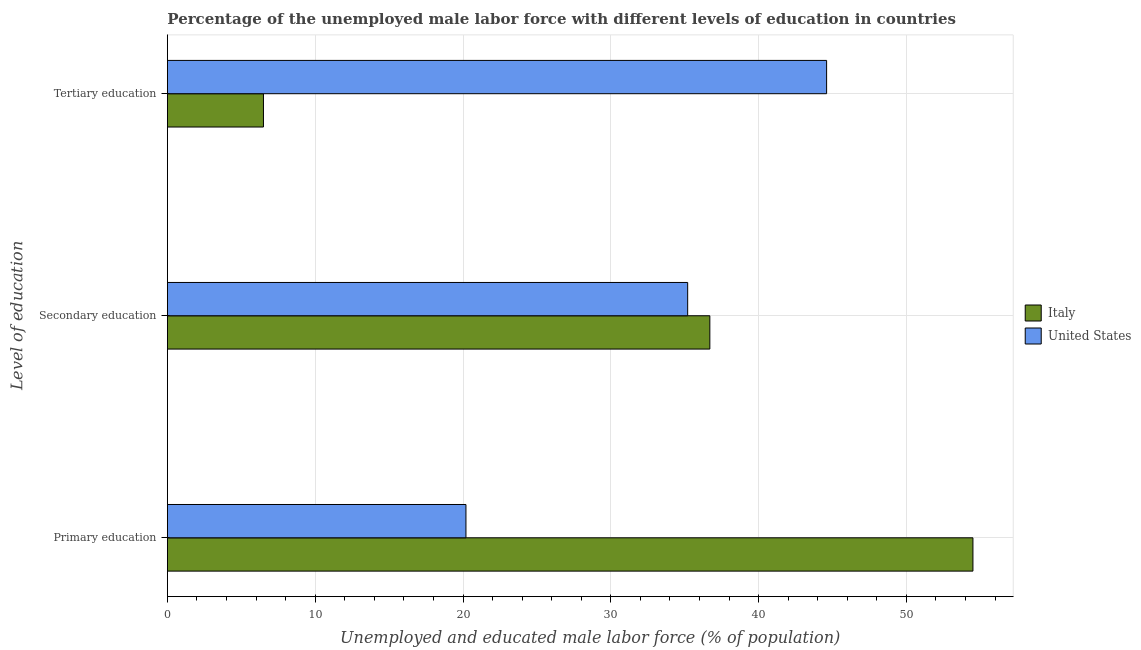How many different coloured bars are there?
Offer a terse response. 2. How many groups of bars are there?
Make the answer very short. 3. Are the number of bars per tick equal to the number of legend labels?
Your answer should be compact. Yes. How many bars are there on the 3rd tick from the bottom?
Keep it short and to the point. 2. What is the label of the 2nd group of bars from the top?
Your response must be concise. Secondary education. What is the percentage of male labor force who received tertiary education in Italy?
Provide a succinct answer. 6.5. Across all countries, what is the maximum percentage of male labor force who received secondary education?
Offer a terse response. 36.7. Across all countries, what is the minimum percentage of male labor force who received primary education?
Make the answer very short. 20.2. In which country was the percentage of male labor force who received primary education maximum?
Provide a short and direct response. Italy. In which country was the percentage of male labor force who received secondary education minimum?
Your answer should be very brief. United States. What is the total percentage of male labor force who received tertiary education in the graph?
Your answer should be very brief. 51.1. What is the difference between the percentage of male labor force who received primary education in United States and that in Italy?
Your response must be concise. -34.3. What is the difference between the percentage of male labor force who received primary education in Italy and the percentage of male labor force who received secondary education in United States?
Offer a very short reply. 19.3. What is the average percentage of male labor force who received primary education per country?
Give a very brief answer. 37.35. What is the difference between the percentage of male labor force who received tertiary education and percentage of male labor force who received primary education in Italy?
Offer a terse response. -48. In how many countries, is the percentage of male labor force who received primary education greater than 18 %?
Ensure brevity in your answer.  2. What is the ratio of the percentage of male labor force who received primary education in Italy to that in United States?
Make the answer very short. 2.7. Is the percentage of male labor force who received secondary education in Italy less than that in United States?
Make the answer very short. No. What is the difference between the highest and the second highest percentage of male labor force who received secondary education?
Your response must be concise. 1.5. What is the difference between the highest and the lowest percentage of male labor force who received tertiary education?
Offer a terse response. 38.1. In how many countries, is the percentage of male labor force who received secondary education greater than the average percentage of male labor force who received secondary education taken over all countries?
Ensure brevity in your answer.  1. What does the 2nd bar from the top in Secondary education represents?
Keep it short and to the point. Italy. What does the 1st bar from the bottom in Primary education represents?
Your answer should be very brief. Italy. How many bars are there?
Make the answer very short. 6. Are all the bars in the graph horizontal?
Offer a very short reply. Yes. What is the difference between two consecutive major ticks on the X-axis?
Your answer should be compact. 10. Are the values on the major ticks of X-axis written in scientific E-notation?
Your answer should be compact. No. Where does the legend appear in the graph?
Your answer should be very brief. Center right. What is the title of the graph?
Ensure brevity in your answer.  Percentage of the unemployed male labor force with different levels of education in countries. Does "Bahamas" appear as one of the legend labels in the graph?
Your answer should be compact. No. What is the label or title of the X-axis?
Provide a succinct answer. Unemployed and educated male labor force (% of population). What is the label or title of the Y-axis?
Provide a short and direct response. Level of education. What is the Unemployed and educated male labor force (% of population) in Italy in Primary education?
Keep it short and to the point. 54.5. What is the Unemployed and educated male labor force (% of population) in United States in Primary education?
Offer a very short reply. 20.2. What is the Unemployed and educated male labor force (% of population) of Italy in Secondary education?
Keep it short and to the point. 36.7. What is the Unemployed and educated male labor force (% of population) of United States in Secondary education?
Give a very brief answer. 35.2. What is the Unemployed and educated male labor force (% of population) in Italy in Tertiary education?
Your answer should be compact. 6.5. What is the Unemployed and educated male labor force (% of population) in United States in Tertiary education?
Keep it short and to the point. 44.6. Across all Level of education, what is the maximum Unemployed and educated male labor force (% of population) of Italy?
Provide a succinct answer. 54.5. Across all Level of education, what is the maximum Unemployed and educated male labor force (% of population) of United States?
Give a very brief answer. 44.6. Across all Level of education, what is the minimum Unemployed and educated male labor force (% of population) of Italy?
Give a very brief answer. 6.5. Across all Level of education, what is the minimum Unemployed and educated male labor force (% of population) of United States?
Make the answer very short. 20.2. What is the total Unemployed and educated male labor force (% of population) in Italy in the graph?
Offer a terse response. 97.7. What is the difference between the Unemployed and educated male labor force (% of population) of United States in Primary education and that in Secondary education?
Provide a short and direct response. -15. What is the difference between the Unemployed and educated male labor force (% of population) in Italy in Primary education and that in Tertiary education?
Make the answer very short. 48. What is the difference between the Unemployed and educated male labor force (% of population) in United States in Primary education and that in Tertiary education?
Provide a short and direct response. -24.4. What is the difference between the Unemployed and educated male labor force (% of population) in Italy in Secondary education and that in Tertiary education?
Your answer should be very brief. 30.2. What is the difference between the Unemployed and educated male labor force (% of population) of United States in Secondary education and that in Tertiary education?
Make the answer very short. -9.4. What is the difference between the Unemployed and educated male labor force (% of population) in Italy in Primary education and the Unemployed and educated male labor force (% of population) in United States in Secondary education?
Your response must be concise. 19.3. What is the average Unemployed and educated male labor force (% of population) in Italy per Level of education?
Make the answer very short. 32.57. What is the average Unemployed and educated male labor force (% of population) of United States per Level of education?
Give a very brief answer. 33.33. What is the difference between the Unemployed and educated male labor force (% of population) of Italy and Unemployed and educated male labor force (% of population) of United States in Primary education?
Keep it short and to the point. 34.3. What is the difference between the Unemployed and educated male labor force (% of population) in Italy and Unemployed and educated male labor force (% of population) in United States in Secondary education?
Make the answer very short. 1.5. What is the difference between the Unemployed and educated male labor force (% of population) in Italy and Unemployed and educated male labor force (% of population) in United States in Tertiary education?
Ensure brevity in your answer.  -38.1. What is the ratio of the Unemployed and educated male labor force (% of population) in Italy in Primary education to that in Secondary education?
Offer a terse response. 1.49. What is the ratio of the Unemployed and educated male labor force (% of population) of United States in Primary education to that in Secondary education?
Your answer should be compact. 0.57. What is the ratio of the Unemployed and educated male labor force (% of population) in Italy in Primary education to that in Tertiary education?
Your answer should be very brief. 8.38. What is the ratio of the Unemployed and educated male labor force (% of population) in United States in Primary education to that in Tertiary education?
Provide a short and direct response. 0.45. What is the ratio of the Unemployed and educated male labor force (% of population) of Italy in Secondary education to that in Tertiary education?
Your answer should be compact. 5.65. What is the ratio of the Unemployed and educated male labor force (% of population) of United States in Secondary education to that in Tertiary education?
Ensure brevity in your answer.  0.79. What is the difference between the highest and the second highest Unemployed and educated male labor force (% of population) of Italy?
Provide a short and direct response. 17.8. What is the difference between the highest and the lowest Unemployed and educated male labor force (% of population) of United States?
Provide a short and direct response. 24.4. 